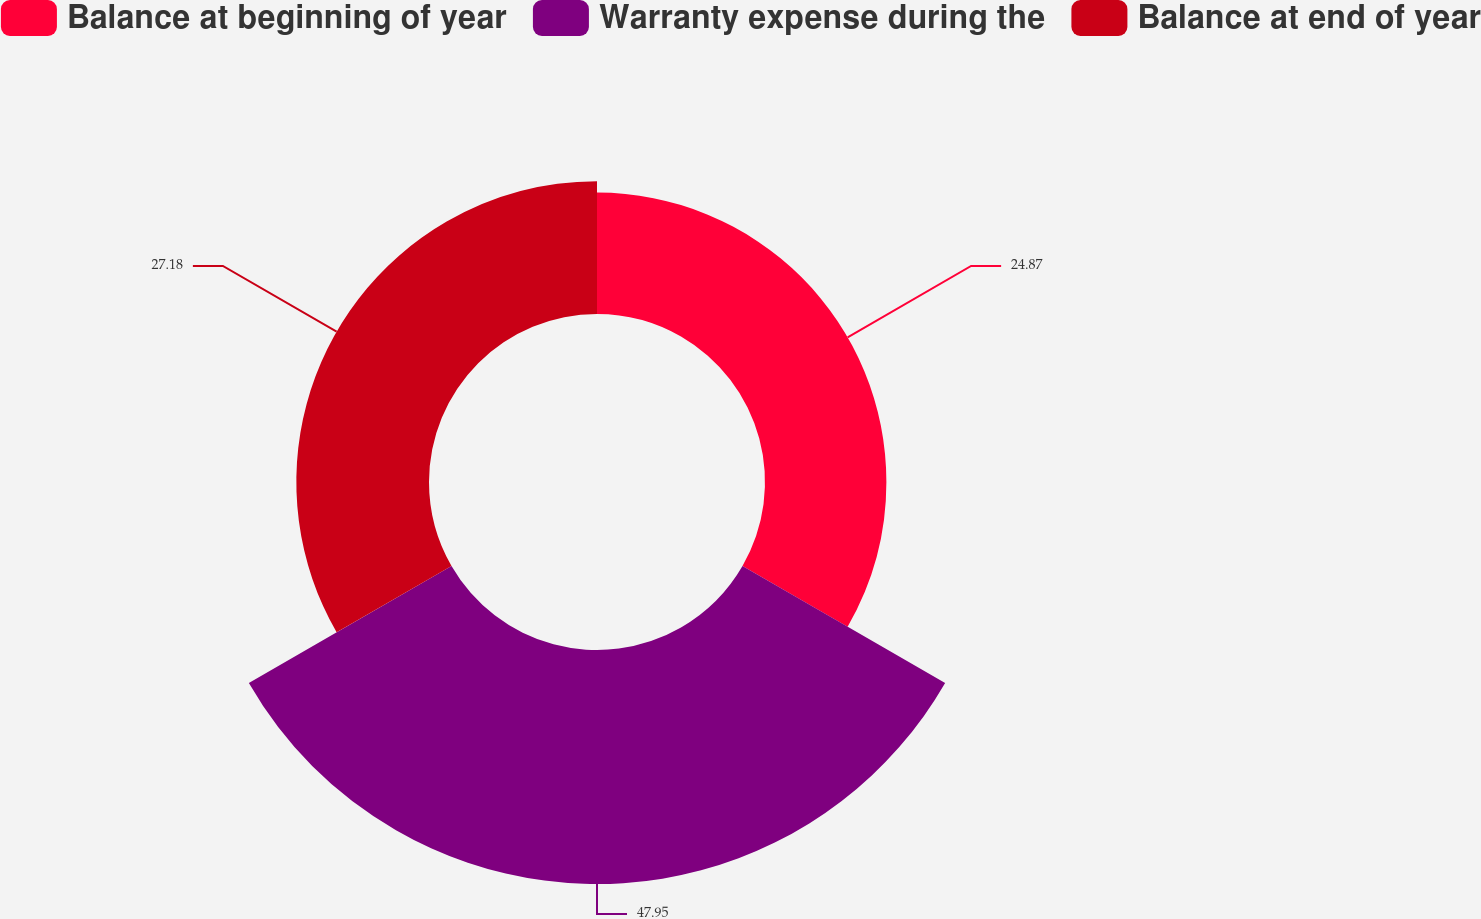<chart> <loc_0><loc_0><loc_500><loc_500><pie_chart><fcel>Balance at beginning of year<fcel>Warranty expense during the<fcel>Balance at end of year<nl><fcel>24.87%<fcel>47.94%<fcel>27.18%<nl></chart> 